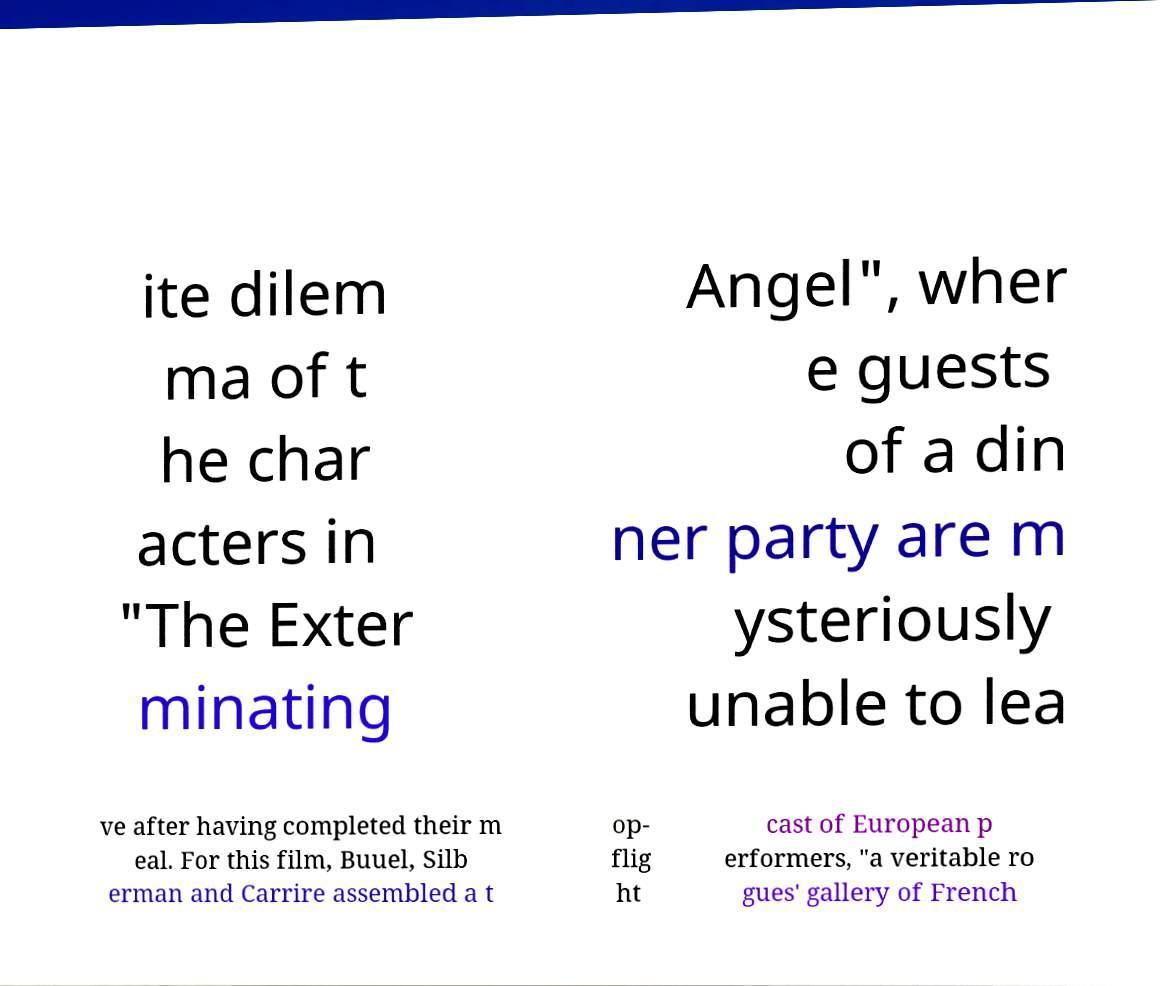Could you extract and type out the text from this image? ite dilem ma of t he char acters in "The Exter minating Angel", wher e guests of a din ner party are m ysteriously unable to lea ve after having completed their m eal. For this film, Buuel, Silb erman and Carrire assembled a t op- flig ht cast of European p erformers, "a veritable ro gues' gallery of French 